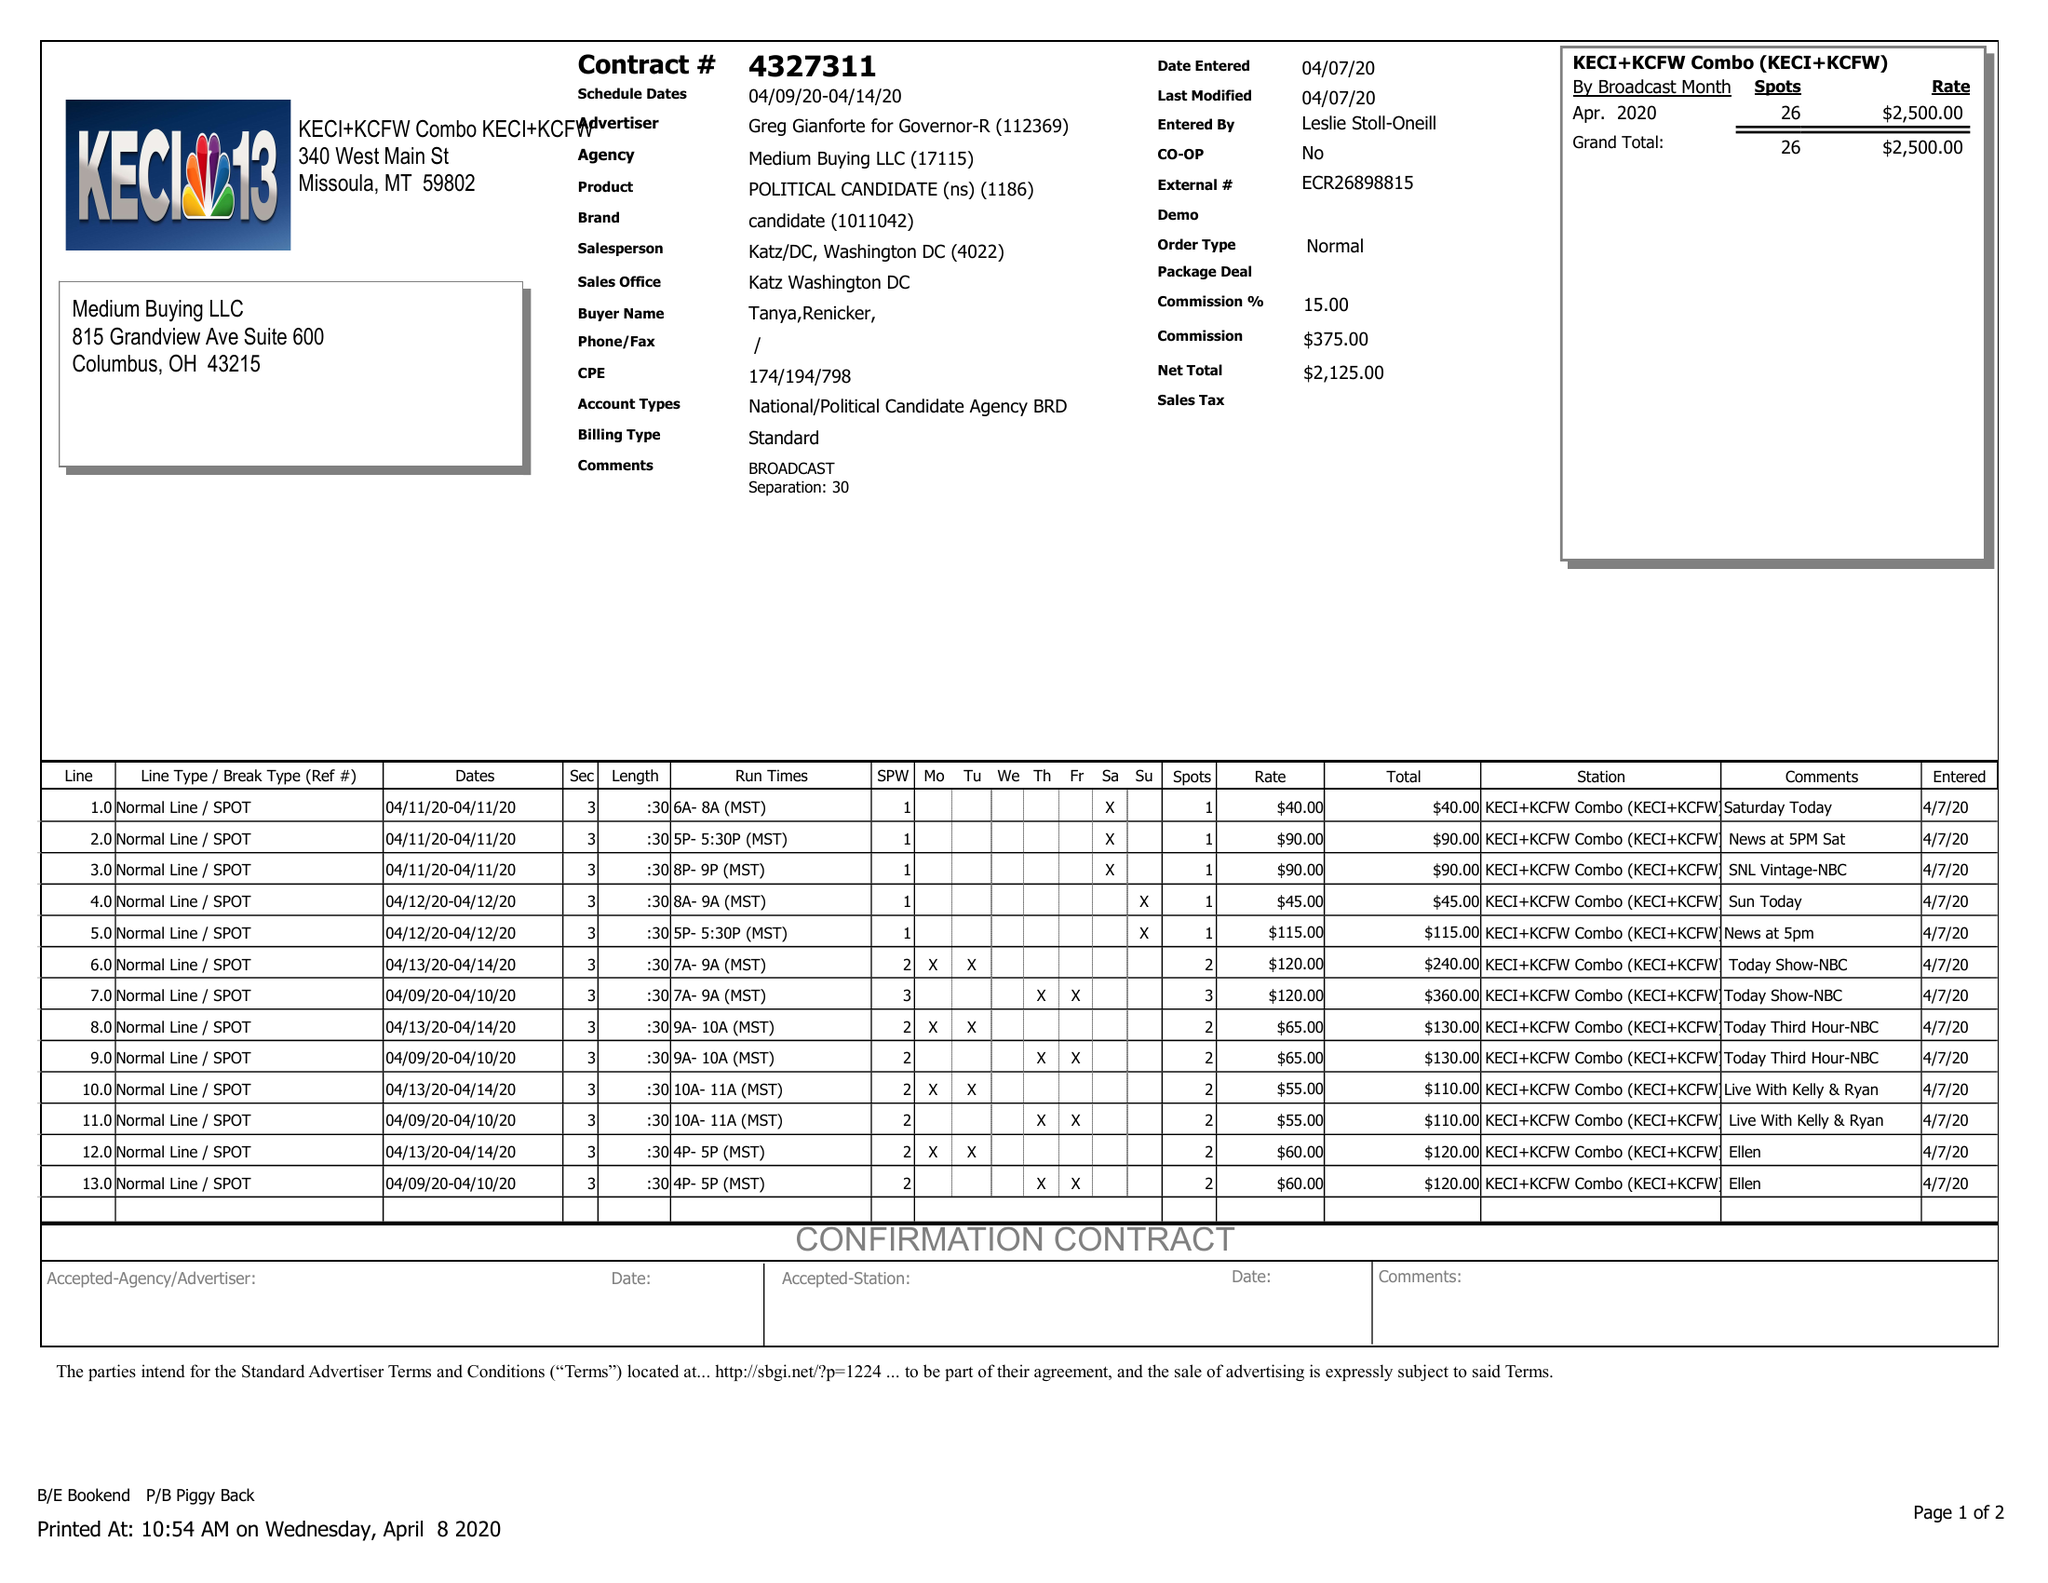What is the value for the gross_amount?
Answer the question using a single word or phrase. 2500.00 